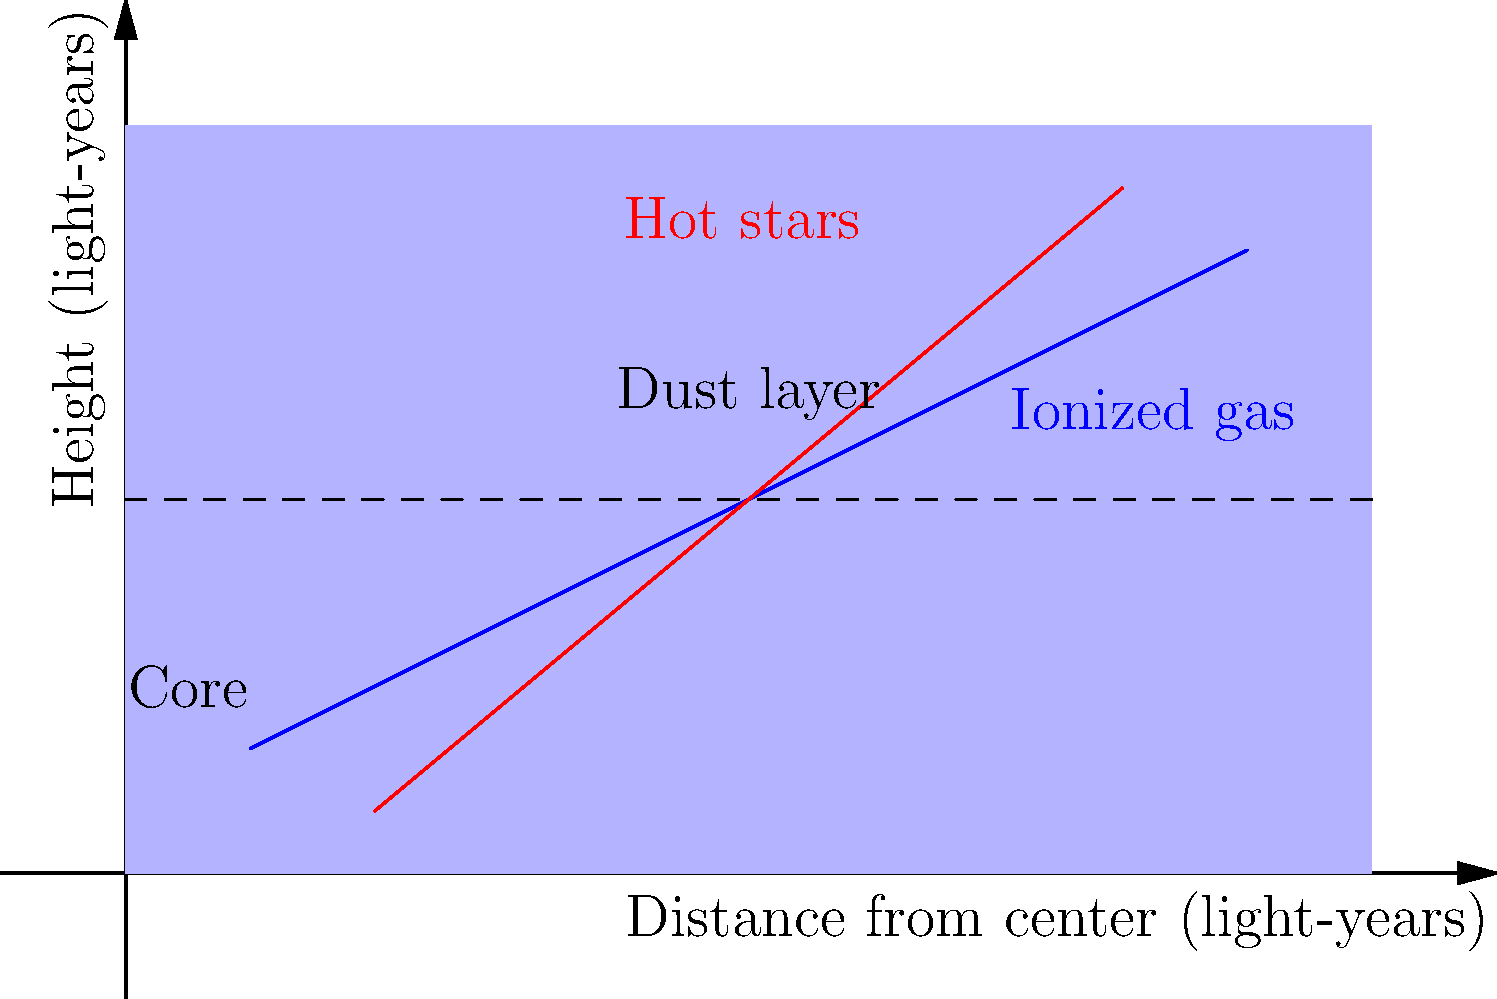In the labeled cross-section of a nebula shown above, which component is most likely to be the primary source of the nebula's visible light emission, and how might this relate to the concept of economic stimulus in your field? To answer this question, let's analyze the components of the nebula and their properties:

1. Dust layer: This is typically composed of cold, dense material that absorbs and scatters light rather than emitting it.

2. Ionized gas: This is a key component for light emission in nebulae. When heated or excited, ionized gas can emit light at specific wavelengths.

3. Hot stars: These are the most energetic objects in the nebula and are the primary energy source for the entire structure.

4. Core: This central region is often where star formation occurs but may not be the primary light source for the entire nebula.

The hot stars are the most likely primary source of visible light emission in the nebula. They provide the energy to ionize and heat the surrounding gas, causing it to glow.

Relating this to economic stimulus:
1. Hot stars act as the "stimulus" in the nebula's economy, providing energy to the system.
2. The ionized gas can be seen as the "market," responding to the stimulus by emitting light (economic activity).
3. The dust layer could represent economic barriers or inefficiencies that absorb or redirect the stimulus effects.
4. The core might be analogous to the central bank or government, where new "stimuli" (stars) are formed.

Just as economists debate the effectiveness of quantitative easing as a form of economic stimulus, astrophysicists might discuss the efficiency of energy transfer from hot stars to the visible light emission of the nebula. Both scenarios involve complex systems where the input of energy or resources doesn't always directly translate to the desired output.
Answer: Hot stars 